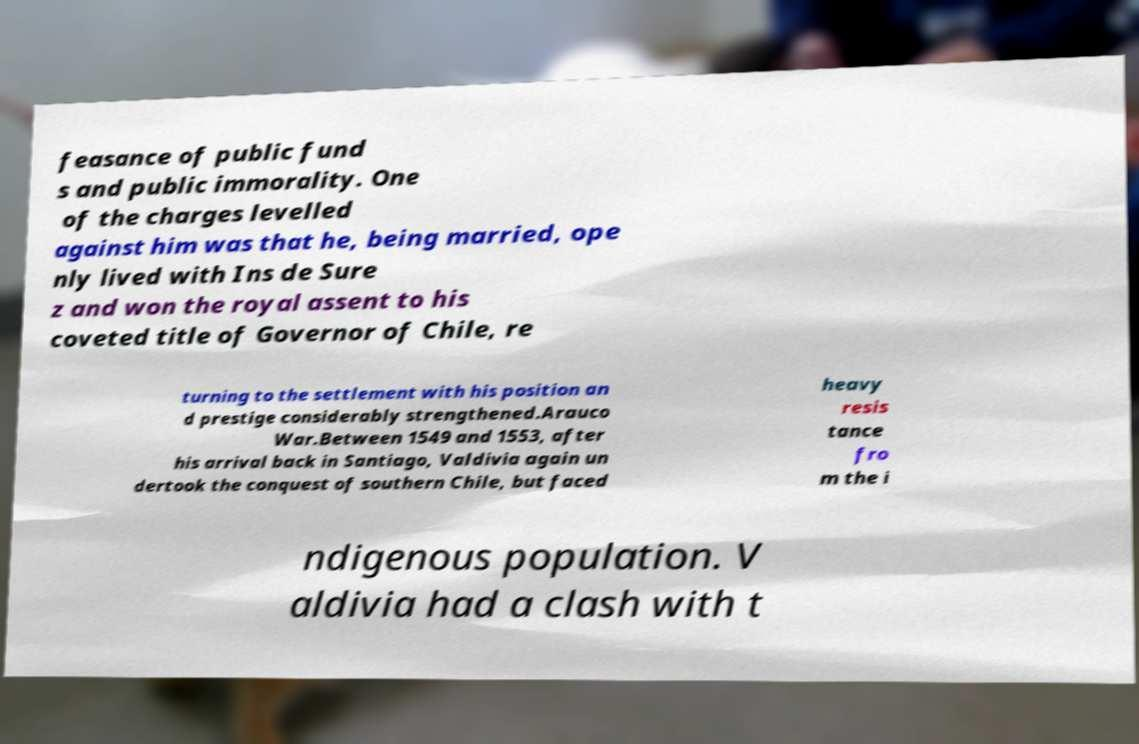Please identify and transcribe the text found in this image. feasance of public fund s and public immorality. One of the charges levelled against him was that he, being married, ope nly lived with Ins de Sure z and won the royal assent to his coveted title of Governor of Chile, re turning to the settlement with his position an d prestige considerably strengthened.Arauco War.Between 1549 and 1553, after his arrival back in Santiago, Valdivia again un dertook the conquest of southern Chile, but faced heavy resis tance fro m the i ndigenous population. V aldivia had a clash with t 